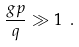Convert formula to latex. <formula><loc_0><loc_0><loc_500><loc_500>\frac { g p } { q } \gg 1 \ .</formula> 